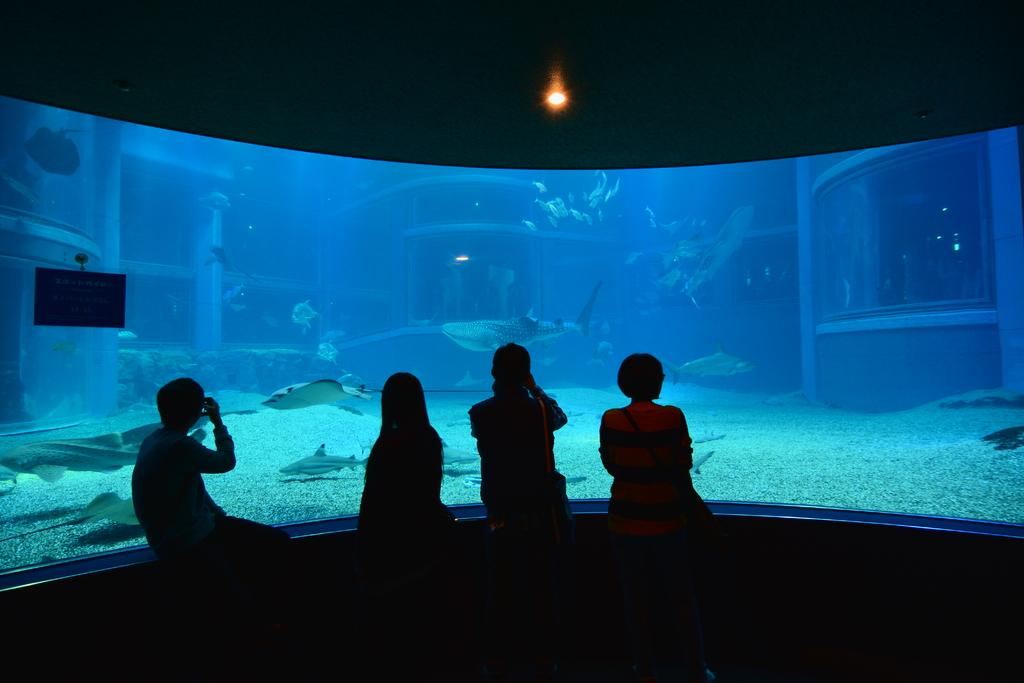How many people are in the image? There are people in the image, but the exact number is not specified. What is located in front of the people? There is a big aquarium in front of the people. What can be seen inside the aquarium? There are fishes and stones inside the aquarium. What is the source of light for the aquarium? There is a light at the top of the aquarium. Can you see a rabbit jumping near the window in the image? There is no rabbit or window present in the image. Where is the kitty playing with a ball of yarn in the image? There is no kitty or ball of yarn present in the image. 